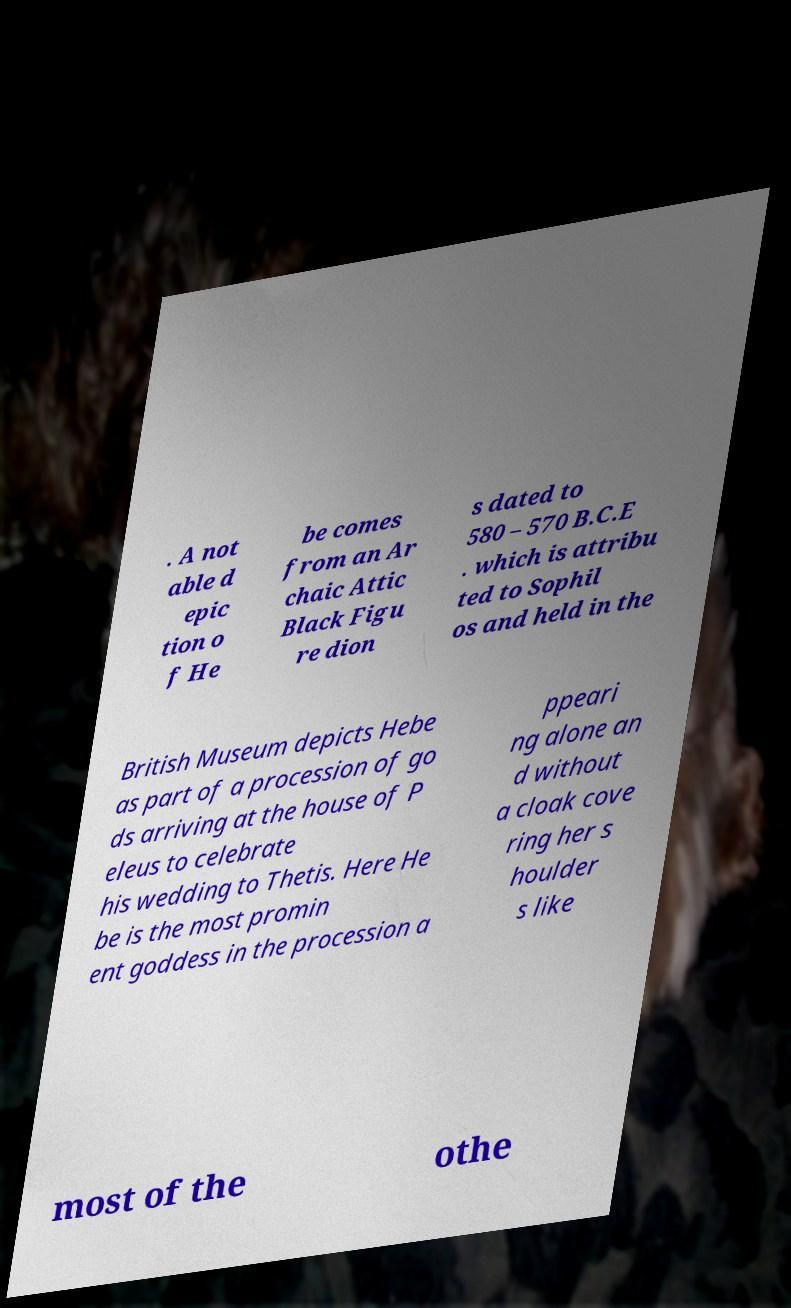Please identify and transcribe the text found in this image. . A not able d epic tion o f He be comes from an Ar chaic Attic Black Figu re dion s dated to 580 – 570 B.C.E . which is attribu ted to Sophil os and held in the British Museum depicts Hebe as part of a procession of go ds arriving at the house of P eleus to celebrate his wedding to Thetis. Here He be is the most promin ent goddess in the procession a ppeari ng alone an d without a cloak cove ring her s houlder s like most of the othe 